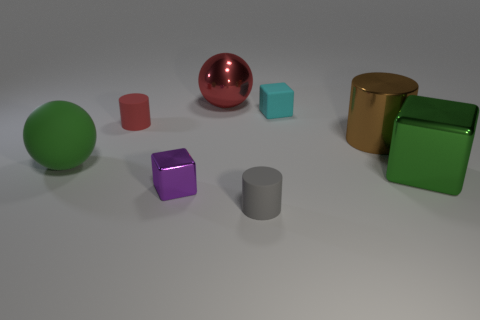Subtract all metal cubes. How many cubes are left? 1 Subtract 1 blocks. How many blocks are left? 2 Add 1 gray things. How many objects exist? 9 Subtract all green cubes. How many cubes are left? 2 Subtract all balls. How many objects are left? 6 Subtract all red spheres. Subtract all purple cylinders. How many spheres are left? 1 Subtract all yellow objects. Subtract all big brown cylinders. How many objects are left? 7 Add 4 small purple metallic objects. How many small purple metallic objects are left? 5 Add 3 cyan cubes. How many cyan cubes exist? 4 Subtract 0 blue cubes. How many objects are left? 8 